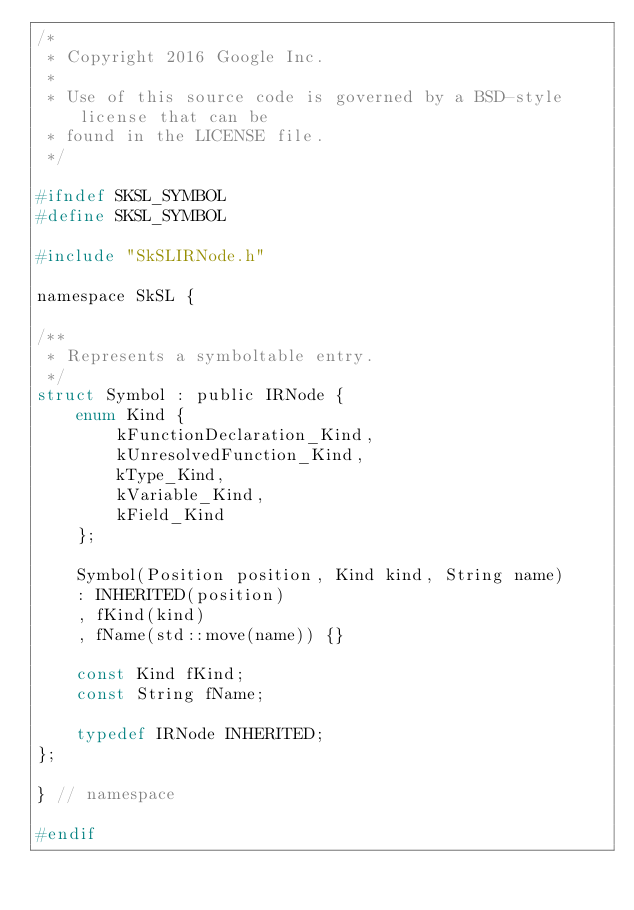<code> <loc_0><loc_0><loc_500><loc_500><_C_>/*
 * Copyright 2016 Google Inc.
 *
 * Use of this source code is governed by a BSD-style license that can be
 * found in the LICENSE file.
 */

#ifndef SKSL_SYMBOL
#define SKSL_SYMBOL

#include "SkSLIRNode.h"

namespace SkSL {

/**
 * Represents a symboltable entry.
 */
struct Symbol : public IRNode {
    enum Kind {
        kFunctionDeclaration_Kind,
        kUnresolvedFunction_Kind,
        kType_Kind,
        kVariable_Kind,
        kField_Kind
    };

    Symbol(Position position, Kind kind, String name)
    : INHERITED(position)
    , fKind(kind)
    , fName(std::move(name)) {}

    const Kind fKind;
    const String fName;

    typedef IRNode INHERITED;
};

} // namespace

#endif
</code> 